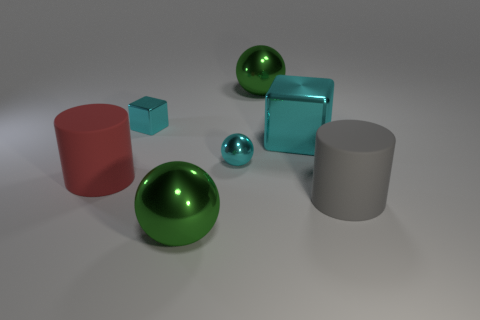Add 3 big cyan metallic objects. How many objects exist? 10 Subtract all large balls. How many balls are left? 1 Subtract all cubes. How many objects are left? 5 Subtract 2 cylinders. How many cylinders are left? 0 Subtract all cyan spheres. How many spheres are left? 2 Add 3 large gray matte cylinders. How many large gray matte cylinders exist? 4 Subtract 0 yellow spheres. How many objects are left? 7 Subtract all red cylinders. Subtract all cyan spheres. How many cylinders are left? 1 Subtract all yellow cylinders. How many green spheres are left? 2 Subtract all large green shiny balls. Subtract all big cyan metal cubes. How many objects are left? 4 